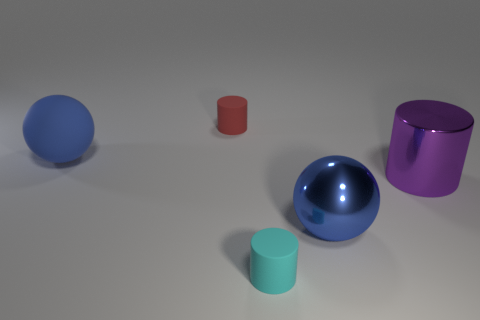What number of cyan objects are the same size as the blue metal thing?
Your answer should be compact. 0. Are any matte blocks visible?
Provide a succinct answer. No. Does the rubber thing on the left side of the red rubber thing have the same shape as the blue object that is right of the blue rubber thing?
Keep it short and to the point. Yes. What number of big objects are either purple metal objects or red things?
Your answer should be very brief. 1. The tiny red thing that is made of the same material as the cyan cylinder is what shape?
Keep it short and to the point. Cylinder. Is the small cyan matte object the same shape as the big purple metallic object?
Provide a succinct answer. Yes. What is the color of the metal cylinder?
Your answer should be compact. Purple. How many objects are big things or tiny blue metallic cubes?
Ensure brevity in your answer.  3. Is the number of blue metal things that are behind the small cyan rubber object less than the number of blue spheres?
Provide a succinct answer. Yes. Are there more big metallic things that are behind the cyan thing than small cyan things behind the blue matte ball?
Your answer should be compact. Yes. 